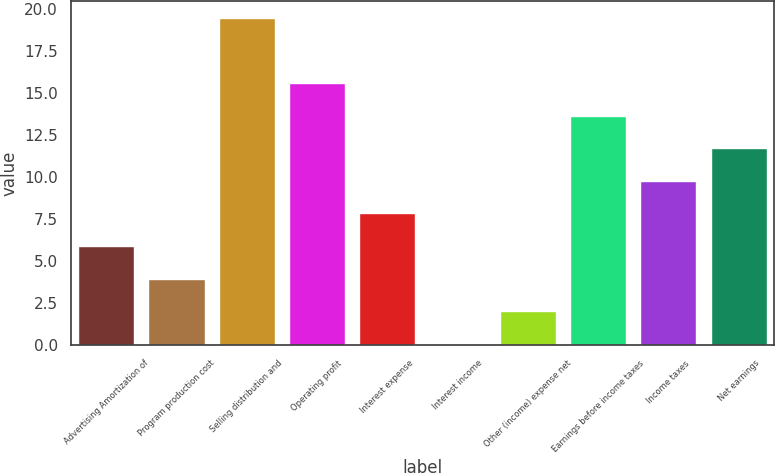Convert chart. <chart><loc_0><loc_0><loc_500><loc_500><bar_chart><fcel>Advertising Amortization of<fcel>Program production cost<fcel>Selling distribution and<fcel>Operating profit<fcel>Interest expense<fcel>Interest income<fcel>Other (income) expense net<fcel>Earnings before income taxes<fcel>Income taxes<fcel>Net earnings<nl><fcel>5.92<fcel>3.98<fcel>19.5<fcel>15.62<fcel>7.86<fcel>0.1<fcel>2.04<fcel>13.68<fcel>9.8<fcel>11.74<nl></chart> 